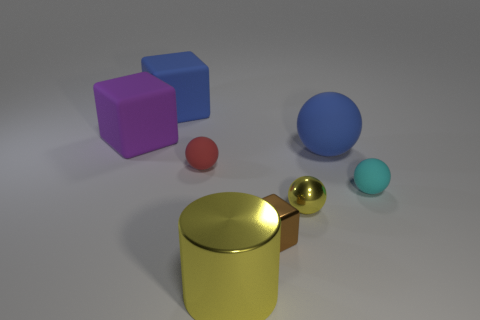How many large yellow things are the same material as the big cylinder?
Your response must be concise. 0. Are there an equal number of big spheres that are behind the blue rubber ball and red matte spheres on the left side of the red rubber sphere?
Make the answer very short. Yes. There is a purple rubber thing; does it have the same shape as the big blue thing that is to the left of the big shiny object?
Your response must be concise. Yes. There is a tiny object that is the same color as the metallic cylinder; what is it made of?
Offer a terse response. Metal. Is there anything else that is the same shape as the cyan thing?
Provide a short and direct response. Yes. Is the small yellow ball made of the same material as the blue object that is to the right of the metallic ball?
Offer a terse response. No. The thing that is left of the blue object behind the large object that is on the right side of the large metallic object is what color?
Ensure brevity in your answer.  Purple. Is there anything else that is the same size as the blue rubber cube?
Make the answer very short. Yes. Is the color of the metallic sphere the same as the big rubber object that is right of the cylinder?
Ensure brevity in your answer.  No. What color is the small metal ball?
Your answer should be very brief. Yellow. 